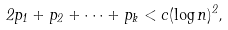<formula> <loc_0><loc_0><loc_500><loc_500>2 p _ { 1 } + p _ { 2 } + \cdots + p _ { k } < c ( \log n ) ^ { 2 } ,</formula> 